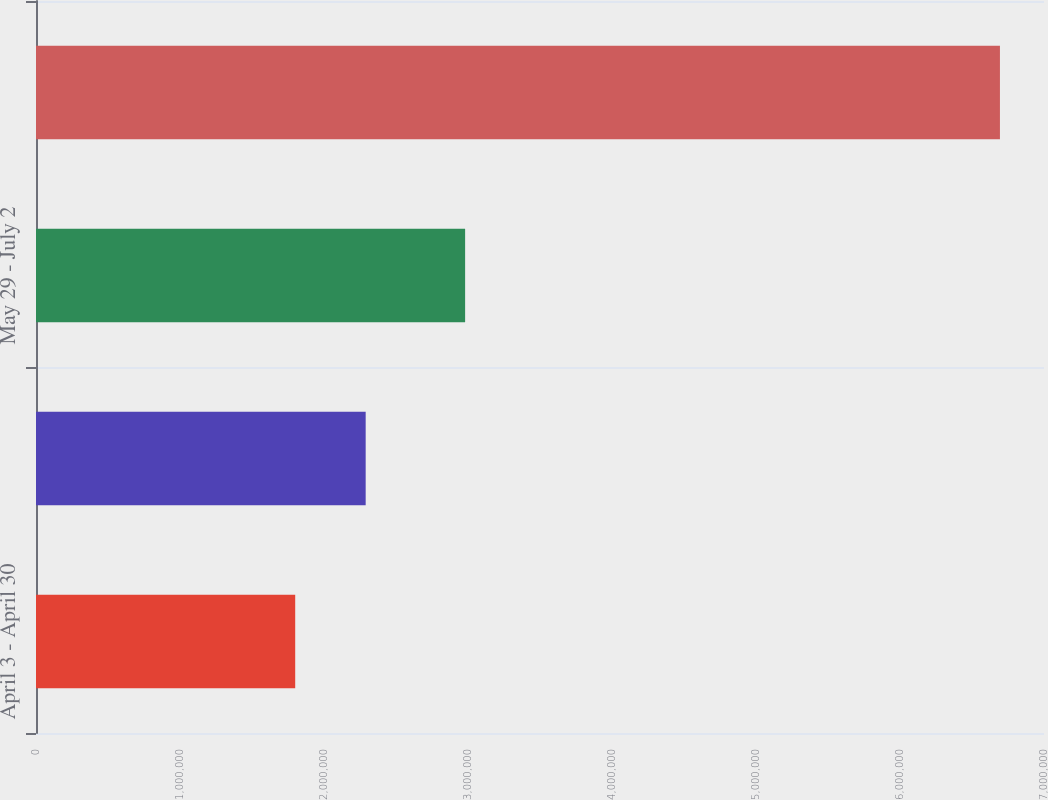Convert chart. <chart><loc_0><loc_0><loc_500><loc_500><bar_chart><fcel>April 3 - April 30<fcel>May 1 - May 28<fcel>May 29 - July 2<fcel>Total<nl><fcel>1.8e+06<fcel>2.2894e+06<fcel>2.98e+06<fcel>6.694e+06<nl></chart> 